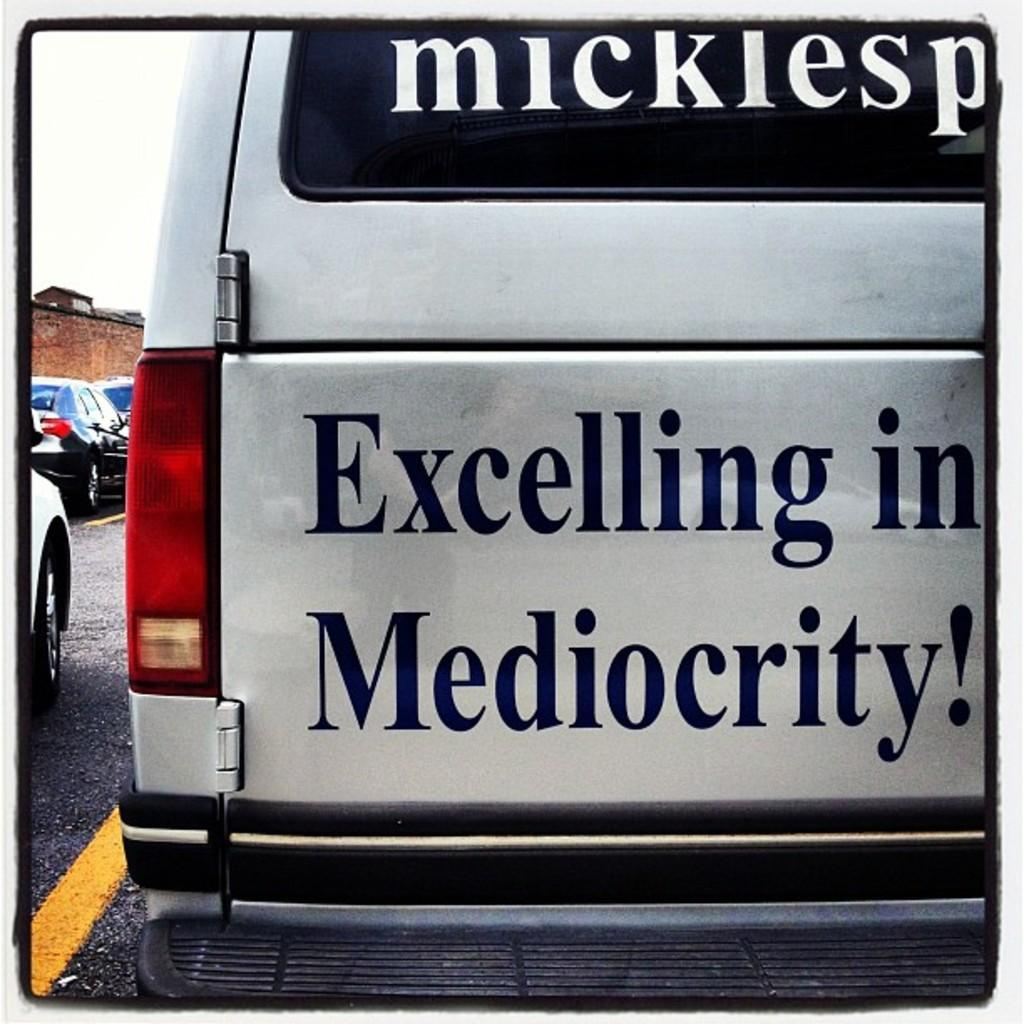What is the main subject of the image? The main subject of the image is the backside of a car. What can be seen on the car? The car has wordings on it that say "excelling in mediocrity," and there is a stop light on the car. What else can be observed in the image? There are other cars visible on the road. What type of paste is being used to fix the current issue with the car? There is no mention of any paste or current issue with the car in the image. 